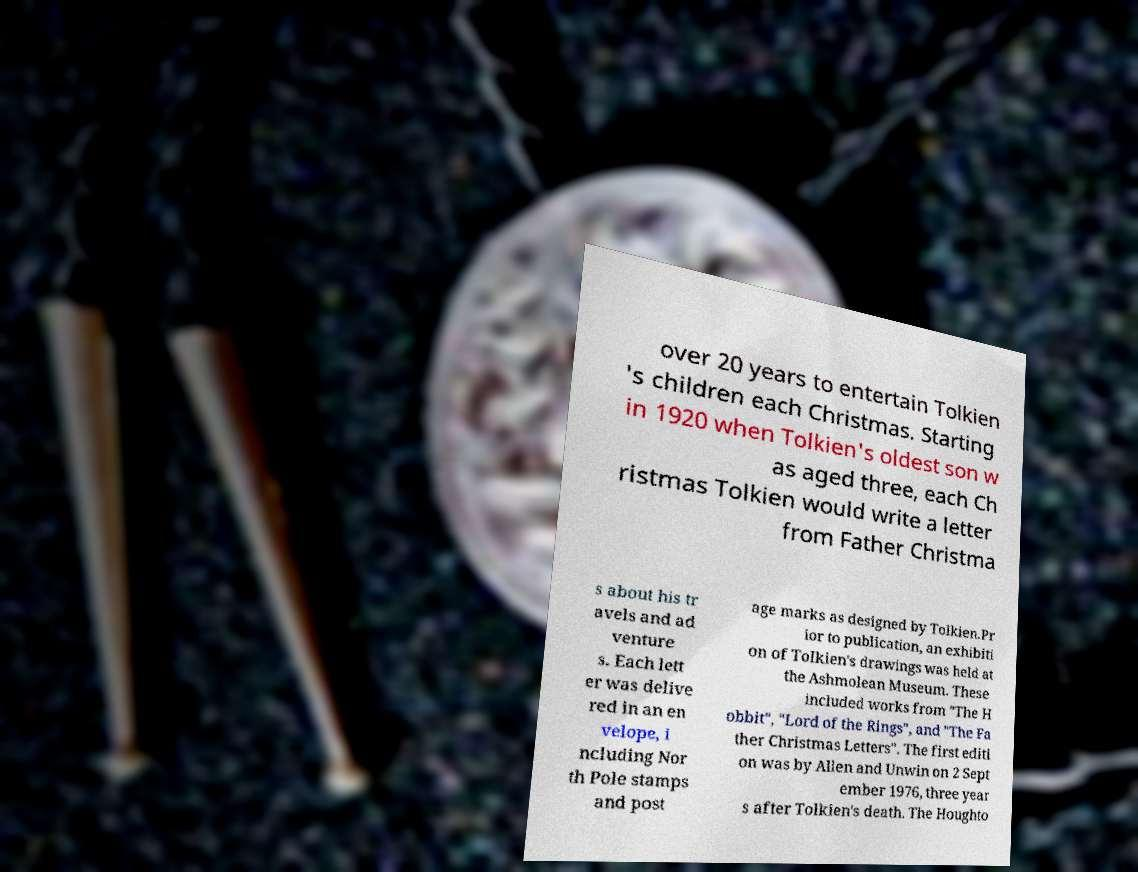What messages or text are displayed in this image? I need them in a readable, typed format. over 20 years to entertain Tolkien 's children each Christmas. Starting in 1920 when Tolkien's oldest son w as aged three, each Ch ristmas Tolkien would write a letter from Father Christma s about his tr avels and ad venture s. Each lett er was delive red in an en velope, i ncluding Nor th Pole stamps and post age marks as designed by Tolkien.Pr ior to publication, an exhibiti on of Tolkien's drawings was held at the Ashmolean Museum. These included works from "The H obbit", "Lord of the Rings", and "The Fa ther Christmas Letters". The first editi on was by Allen and Unwin on 2 Sept ember 1976, three year s after Tolkien's death. The Houghto 